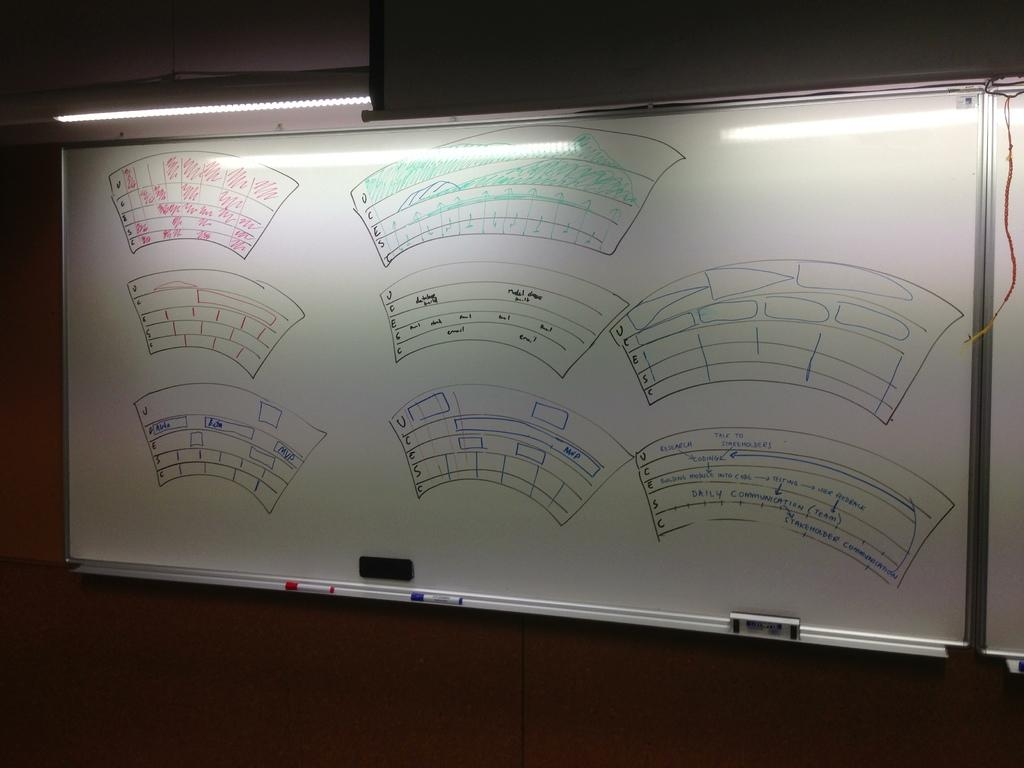What is the main object in the foreground of the image? There is a whiteboard in the foreground of the image. What else can be seen in the foreground of the image? There is a light and a wall in the foreground of the image. Can you describe the setting of the image? The image may have been taken in a hall. What type of cloth is draped over the apple in the image? There is no cloth or apple present in the image. 